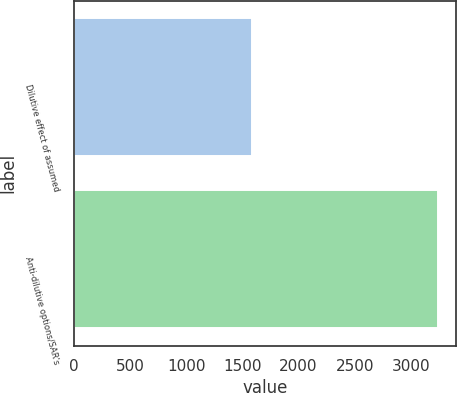Convert chart to OTSL. <chart><loc_0><loc_0><loc_500><loc_500><bar_chart><fcel>Dilutive effect of assumed<fcel>Anti-dilutive options/SAR's<nl><fcel>1588<fcel>3241<nl></chart> 